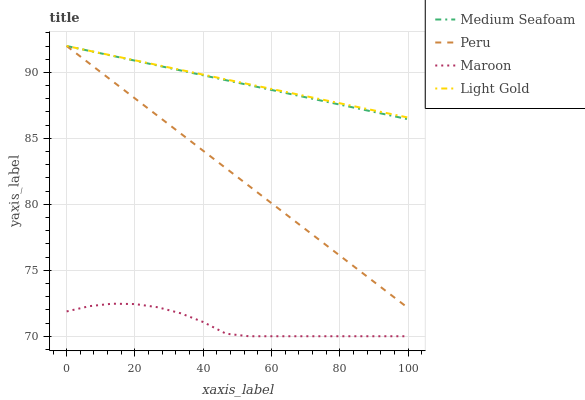Does Maroon have the minimum area under the curve?
Answer yes or no. Yes. Does Light Gold have the maximum area under the curve?
Answer yes or no. Yes. Does Medium Seafoam have the minimum area under the curve?
Answer yes or no. No. Does Medium Seafoam have the maximum area under the curve?
Answer yes or no. No. Is Light Gold the smoothest?
Answer yes or no. Yes. Is Maroon the roughest?
Answer yes or no. Yes. Is Medium Seafoam the smoothest?
Answer yes or no. No. Is Medium Seafoam the roughest?
Answer yes or no. No. Does Medium Seafoam have the lowest value?
Answer yes or no. No. Does Peru have the highest value?
Answer yes or no. Yes. Is Maroon less than Peru?
Answer yes or no. Yes. Is Light Gold greater than Maroon?
Answer yes or no. Yes. Does Light Gold intersect Peru?
Answer yes or no. Yes. Is Light Gold less than Peru?
Answer yes or no. No. Is Light Gold greater than Peru?
Answer yes or no. No. Does Maroon intersect Peru?
Answer yes or no. No. 